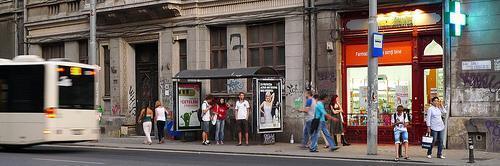How many people?
Give a very brief answer. 11. 